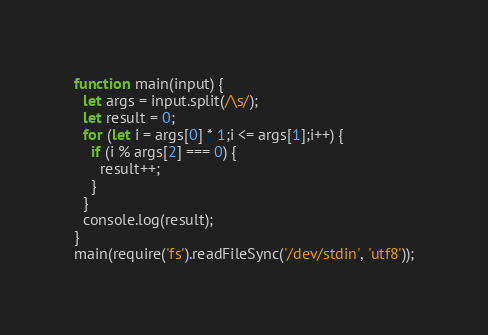Convert code to text. <code><loc_0><loc_0><loc_500><loc_500><_JavaScript_>function main(input) {
  let args = input.split(/\s/);
  let result = 0;
  for (let i = args[0] * 1;i <= args[1];i++) {
    if (i % args[2] === 0) {
      result++;
    }
  }
  console.log(result);
}
main(require('fs').readFileSync('/dev/stdin', 'utf8'));</code> 